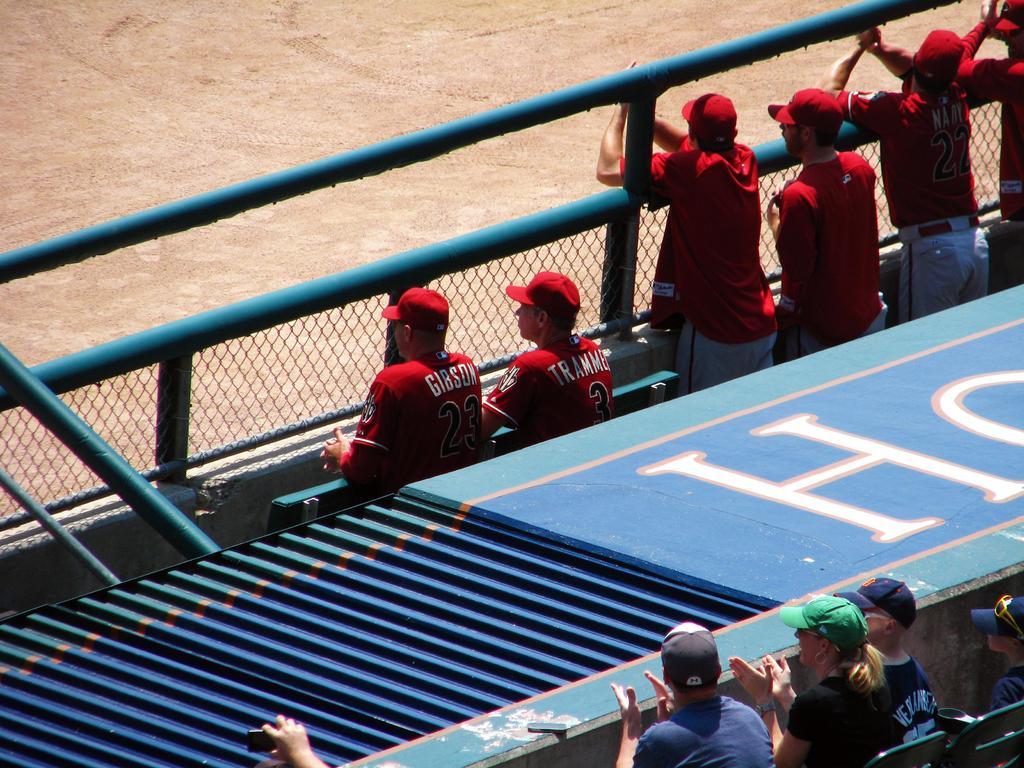Describe this image in one or two sentences. In this image we can see a few people, among them, some are sitting on the chairs and some are standing, also we can see the fence, ground and a stage. 